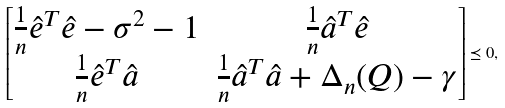<formula> <loc_0><loc_0><loc_500><loc_500>\begin{bmatrix} \frac { 1 } { n } \hat { e } ^ { T } \hat { e } - \sigma ^ { 2 } - 1 & \frac { 1 } { n } \hat { a } ^ { T } \hat { e } \\ \frac { 1 } { n } \hat { e } ^ { T } \hat { a } & \frac { 1 } { n } \hat { a } ^ { T } \hat { a } + \Delta _ { n } ( Q ) - \gamma \end{bmatrix} \preceq 0 ,</formula> 